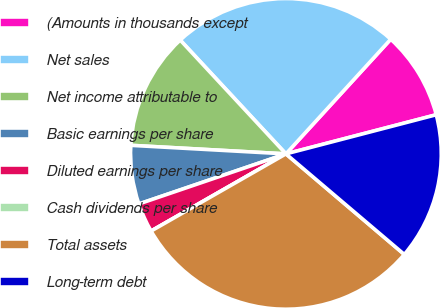Convert chart. <chart><loc_0><loc_0><loc_500><loc_500><pie_chart><fcel>(Amounts in thousands except<fcel>Net sales<fcel>Net income attributable to<fcel>Basic earnings per share<fcel>Diluted earnings per share<fcel>Cash dividends per share<fcel>Total assets<fcel>Long-term debt<nl><fcel>9.16%<fcel>23.7%<fcel>12.21%<fcel>6.1%<fcel>3.05%<fcel>0.0%<fcel>30.52%<fcel>15.26%<nl></chart> 